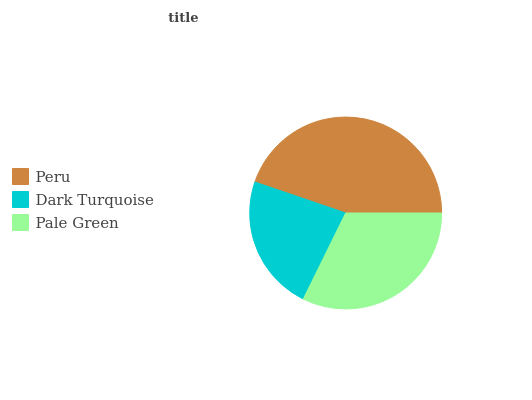Is Dark Turquoise the minimum?
Answer yes or no. Yes. Is Peru the maximum?
Answer yes or no. Yes. Is Pale Green the minimum?
Answer yes or no. No. Is Pale Green the maximum?
Answer yes or no. No. Is Pale Green greater than Dark Turquoise?
Answer yes or no. Yes. Is Dark Turquoise less than Pale Green?
Answer yes or no. Yes. Is Dark Turquoise greater than Pale Green?
Answer yes or no. No. Is Pale Green less than Dark Turquoise?
Answer yes or no. No. Is Pale Green the high median?
Answer yes or no. Yes. Is Pale Green the low median?
Answer yes or no. Yes. Is Dark Turquoise the high median?
Answer yes or no. No. Is Peru the low median?
Answer yes or no. No. 